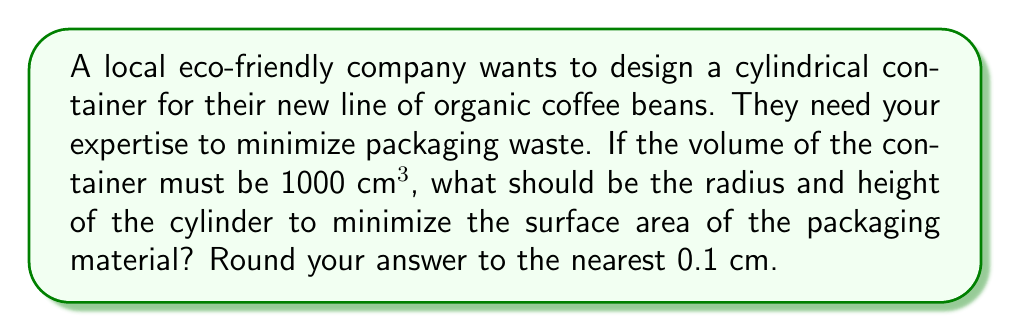Give your solution to this math problem. Let's approach this step-by-step:

1) For a cylinder, we have:
   Volume: $V = \pi r^2 h$
   Surface Area: $SA = 2\pi r^2 + 2\pi rh$

2) We're given that $V = 1000$ cm³. So:
   $1000 = \pi r^2 h$

3) Solve for $h$:
   $h = \frac{1000}{\pi r^2}$

4) Substitute this into the surface area formula:
   $SA = 2\pi r^2 + 2\pi r(\frac{1000}{\pi r^2})$
   $SA = 2\pi r^2 + \frac{2000}{r}$

5) To minimize SA, we find where its derivative equals zero:
   $\frac{dSA}{dr} = 4\pi r - \frac{2000}{r^2} = 0$

6) Solve this equation:
   $4\pi r^3 = 2000$
   $r^3 = \frac{500}{\pi}$
   $r = \sqrt[3]{\frac{500}{\pi}} \approx 5.4$ cm

7) Calculate $h$ using the formula from step 3:
   $h = \frac{1000}{\pi (5.4)^2} \approx 10.9$ cm

8) Rounding to the nearest 0.1 cm:
   $r = 5.4$ cm
   $h = 10.9$ cm

This design minimizes the surface area, thus reducing packaging waste.
Answer: $r = 5.4$ cm, $h = 10.9$ cm 